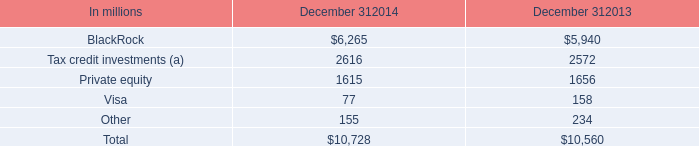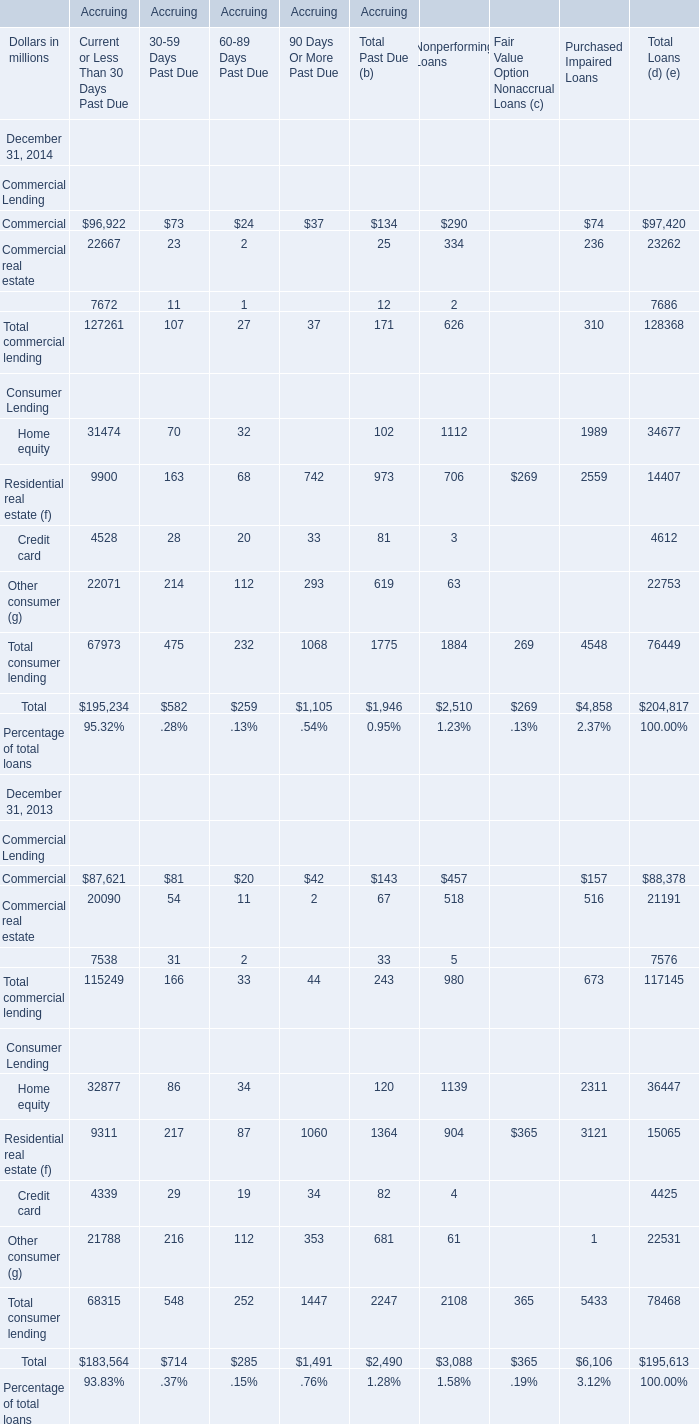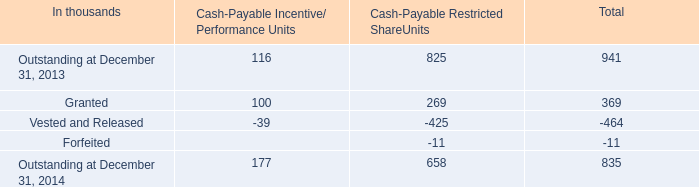for tax credit investments included in our equity investments held by consolidated partnerships , what was the change in billions between december 31 , 2014 and december 31 , 2013? 
Computations: (2.6 - 2.6)
Answer: 0.0. 